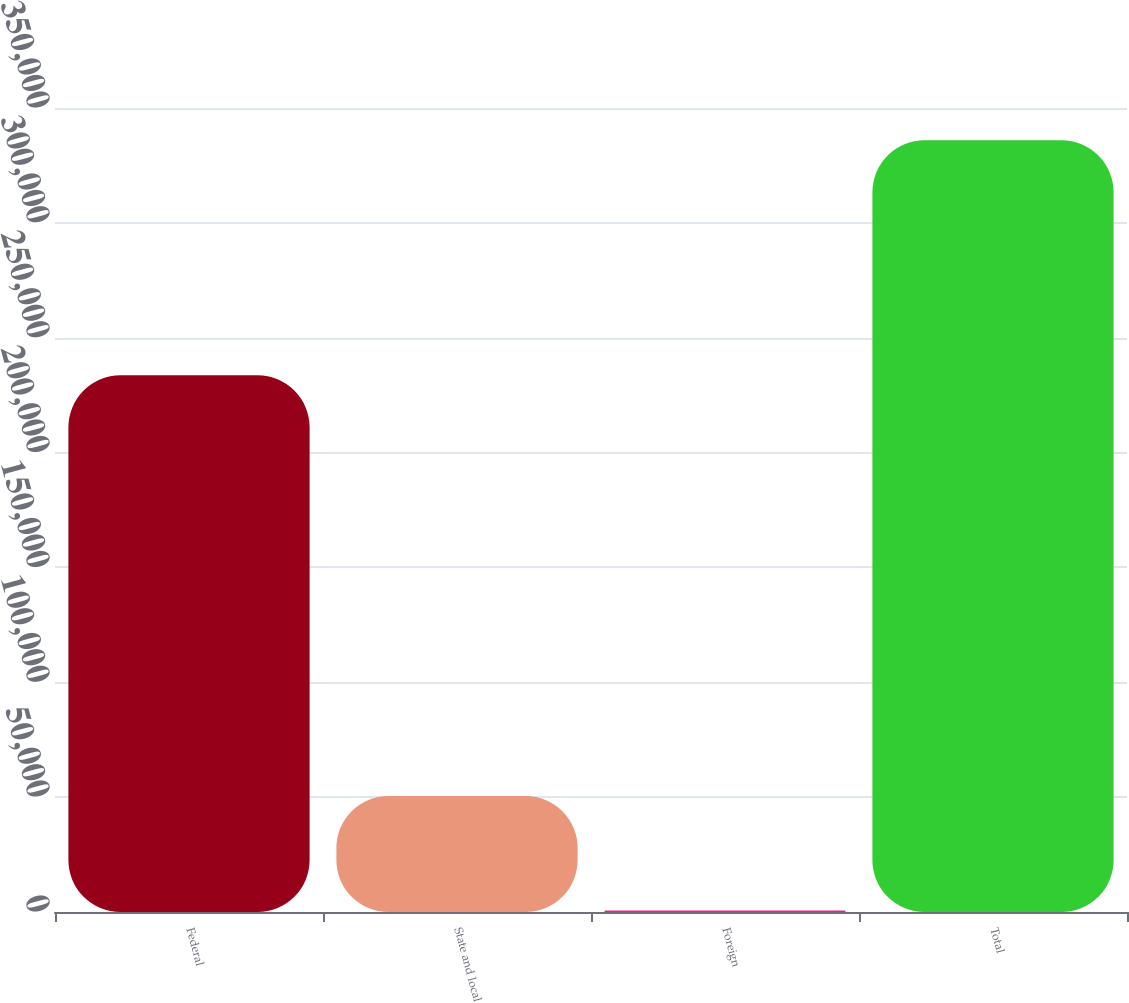<chart> <loc_0><loc_0><loc_500><loc_500><bar_chart><fcel>Federal<fcel>State and local<fcel>Foreign<fcel>Total<nl><fcel>233635<fcel>50527<fcel>682<fcel>335931<nl></chart> 